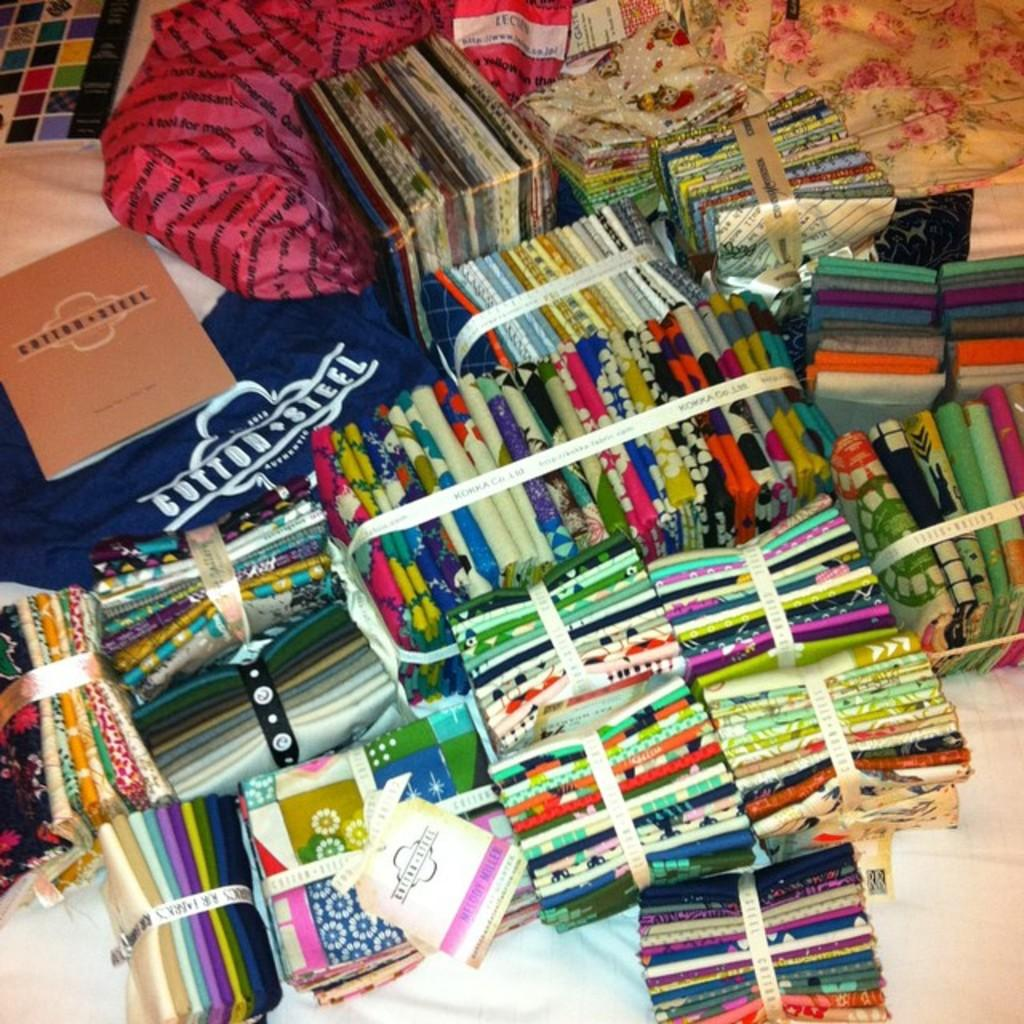<image>
Describe the image concisely. A bunch of merchandise from the brand name Cotton Steel. 